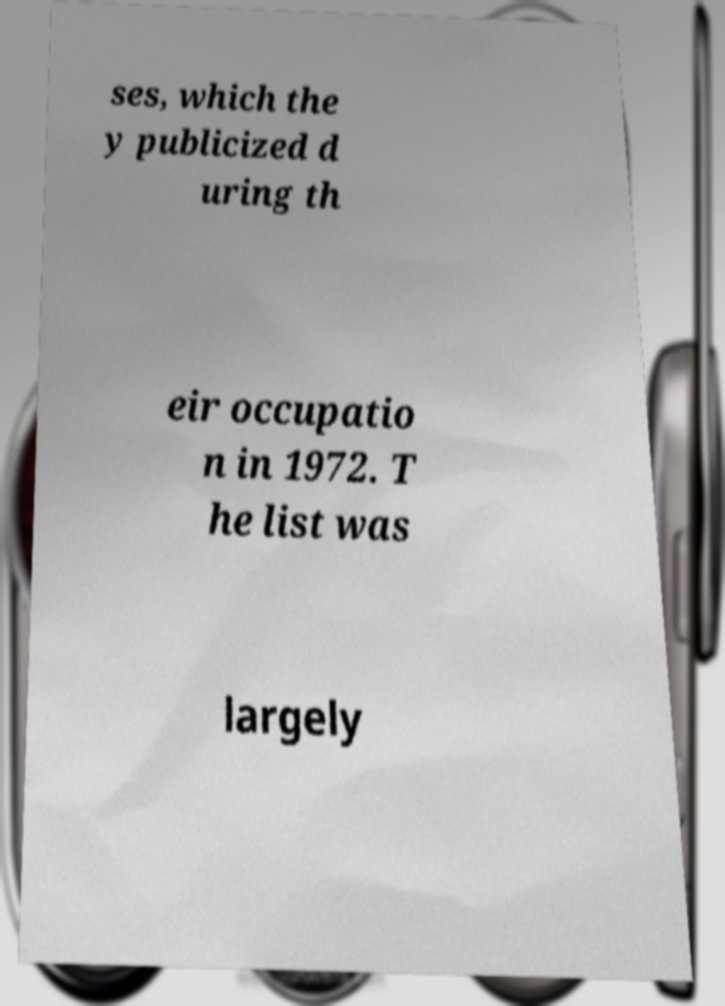Please identify and transcribe the text found in this image. ses, which the y publicized d uring th eir occupatio n in 1972. T he list was largely 